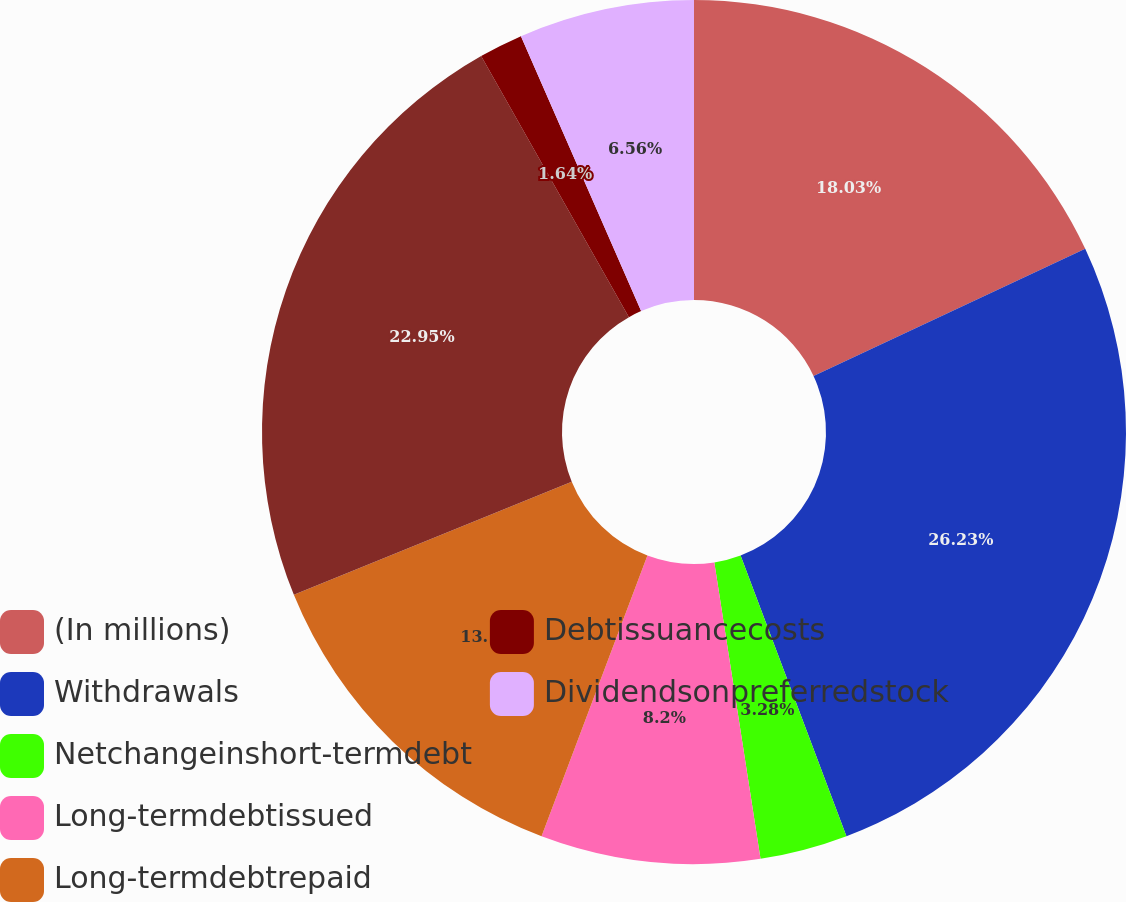Convert chart to OTSL. <chart><loc_0><loc_0><loc_500><loc_500><pie_chart><fcel>(In millions)<fcel>Withdrawals<fcel>Netchangeinshort-termdebt<fcel>Long-termdebtissued<fcel>Long-termdebtrepaid<fcel>Unnamed: 5<fcel>Debtissuancecosts<fcel>Dividendsonpreferredstock<nl><fcel>18.03%<fcel>26.23%<fcel>3.28%<fcel>8.2%<fcel>13.11%<fcel>22.95%<fcel>1.64%<fcel>6.56%<nl></chart> 